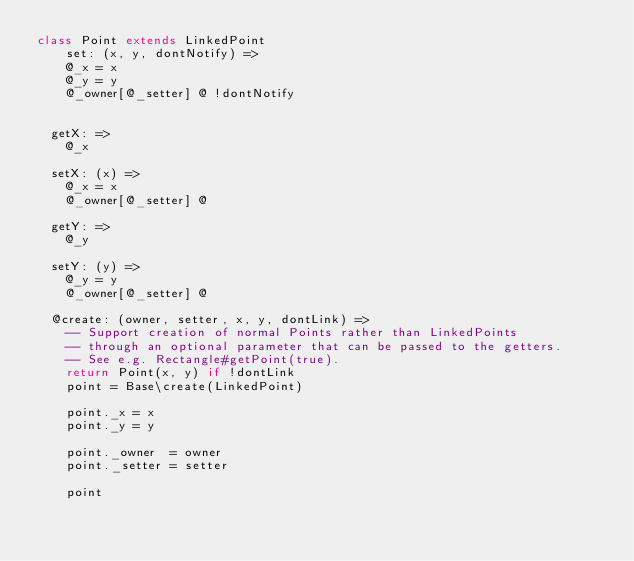<code> <loc_0><loc_0><loc_500><loc_500><_MoonScript_>class Point extends LinkedPoint
	set: (x, y, dontNotify) =>
    @_x = x
    @_y = y
    @_owner[@_setter] @ !dontNotify


  getX: =>
    @_x

  setX: (x) =>
    @_x = x
    @_owner[@_setter] @

  getY: =>
    @_y

  setY: (y) =>
    @_y = y
    @_owner[@_setter] @

  @create: (owner, setter, x, y, dontLink) =>
    -- Support creation of normal Points rather than LinkedPoints
    -- through an optional parameter that can be passed to the getters.
    -- See e.g. Rectangle#getPoint(true).
    return Point(x, y) if !dontLink
    point = Base\create(LinkedPoint)

    point._x = x
    point._y = y

    point._owner  = owner
    point._setter = setter
    
    point
</code> 